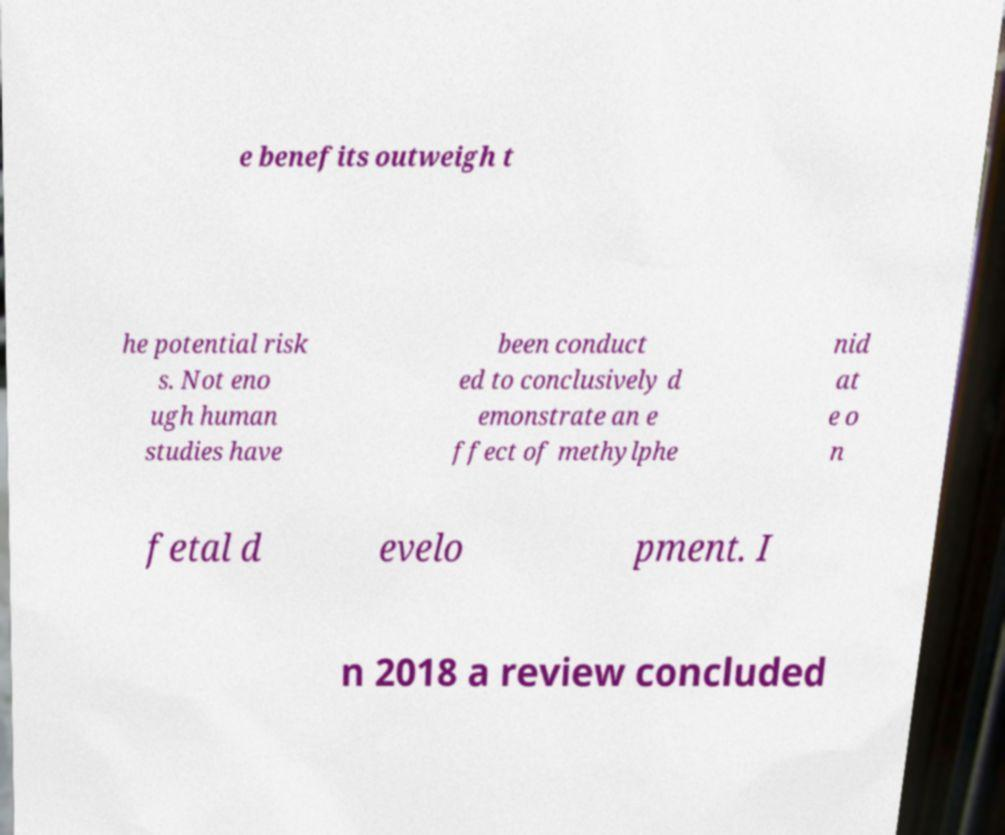Please read and relay the text visible in this image. What does it say? e benefits outweigh t he potential risk s. Not eno ugh human studies have been conduct ed to conclusively d emonstrate an e ffect of methylphe nid at e o n fetal d evelo pment. I n 2018 a review concluded 